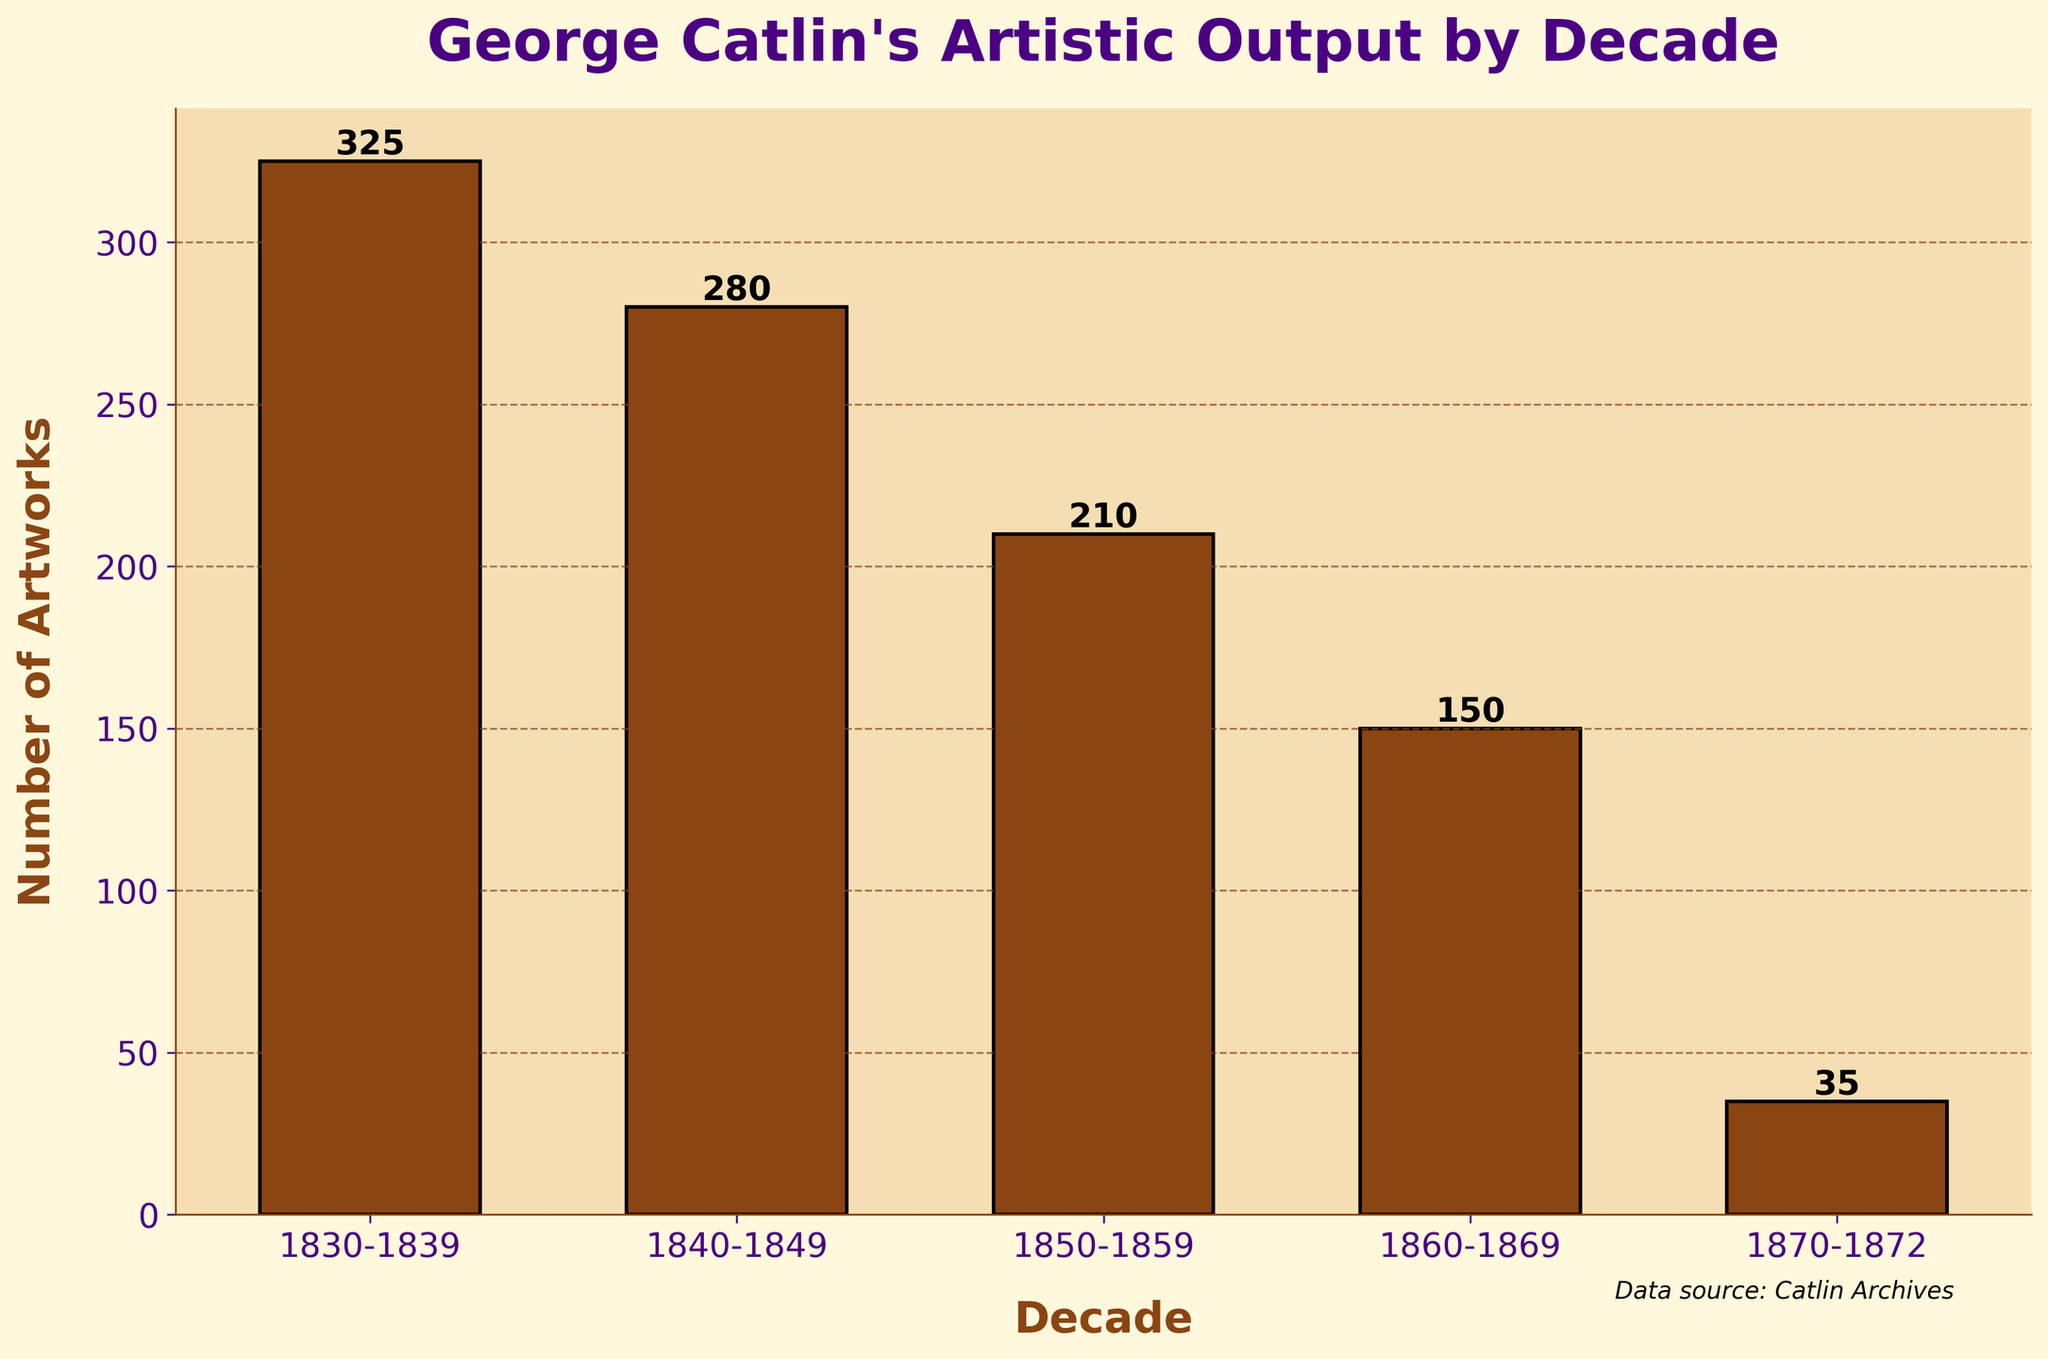How many total artworks did George Catlin produce in the 1830s and 1840s combined? Sum the number of artworks from the 1830s (325) and 1840s (280). 325 + 280 = 605
Answer: 605 Which decade had the highest artistic output by George Catlin? Identify the decade with the highest bar height, corresponding to the value 325, which is in the 1830s.
Answer: 1830s What is the average number of artworks produced by George Catlin per decade from the 1830s to the 1860s? Add the artworks from the 1830s to the 1860s (325 + 280 + 210 + 150) and divide by the number of decades (4). (325 + 280 + 210 + 150) / 4 = 965 / 4 = 241.25
Answer: 241.25 Compare the number of artworks produced in the 1860s and 1870s. In which decade did George Catlin produce more artworks? Compare artworks in the 1860s (150) and 1870s (35). 150 is greater than 35.
Answer: 1860s By how much did George Catlin's artistic output decrease from the 1830s to the 1840s? Subtract the number of artworks in the 1840s (280) from the 1830s (325). 325 - 280 = 45
Answer: 45 What is the color of the bars representing George Catlin's artistic output in the chart? The bars are brown in color.
Answer: Brown By how much did the number of artworks decrease from the 1850s to the 1870s? Subtract the number of artworks in the 1870s (35) from the number in the 1850s (210). 210 - 35 = 175
Answer: 175 Which decade had the lowest artistic output by George Catlin? Identify the decade with the lowest bar height, corresponding to the value 35, which is in the 1870s.
Answer: 1870s What is the total artistic output of George Catlin between 1840 and 1869? Add the number of artworks from the 1840s (280), 1850s (210), and 1860s (150). 280 + 210 + 150 = 640
Answer: 640 